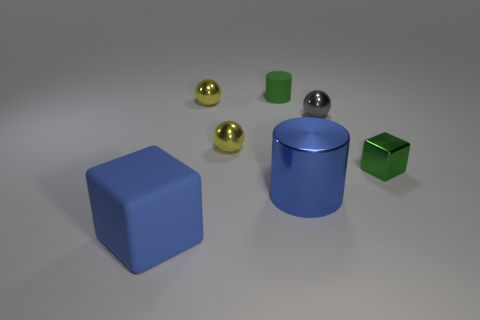Does the small green cylinder have the same material as the large blue cylinder?
Your response must be concise. No. There is another object that is the same shape as the green matte thing; what is its size?
Ensure brevity in your answer.  Large. How many objects are either small things behind the tiny shiny cube or blue objects on the left side of the small rubber cylinder?
Your answer should be compact. 5. Is the number of small cylinders less than the number of blocks?
Your answer should be compact. Yes. Do the blue shiny object and the yellow metallic ball behind the gray ball have the same size?
Your answer should be very brief. No. What number of shiny objects are either tiny cylinders or big objects?
Keep it short and to the point. 1. Are there more large brown balls than small rubber objects?
Provide a short and direct response. No. What is the size of the metallic cylinder that is the same color as the large matte cube?
Keep it short and to the point. Large. There is a green thing that is to the left of the cube that is on the right side of the gray object; what is its shape?
Ensure brevity in your answer.  Cylinder. Is there a gray shiny ball to the left of the tiny yellow shiny ball that is behind the small sphere that is in front of the gray thing?
Offer a terse response. No. 